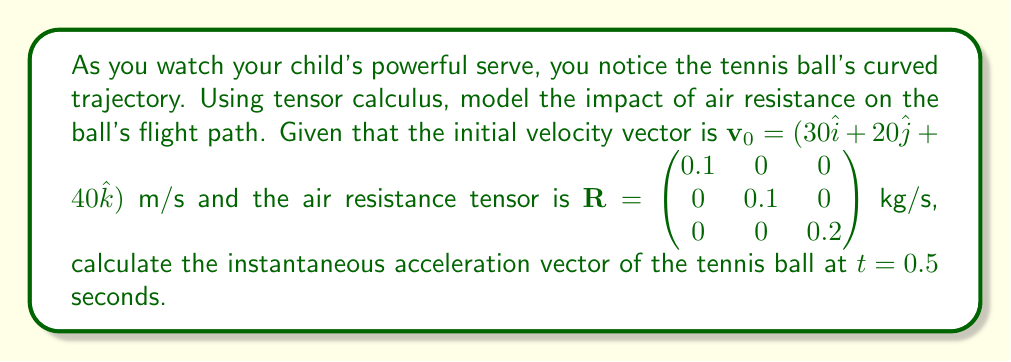Can you solve this math problem? To solve this problem, we'll follow these steps:

1) The equation of motion for a body under air resistance is:

   $$m\frac{d\mathbf{v}}{dt} = m\mathbf{g} - \mathbf{R}\mathbf{v}$$

   where $m$ is the mass of the tennis ball, $\mathbf{g}$ is the gravitational acceleration vector, and $\mathbf{R}$ is the air resistance tensor.

2) The gravitational acceleration vector is $\mathbf{g} = (0, 0, -9.8)$ m/s².

3) We need to find $\mathbf{v}$ at $t = 0.5$ s. We can use the equation:

   $$\mathbf{v}(t) = \mathbf{v}_0 e^{-\frac{\mathbf{R}}{m}t}$$

4) Assuming a standard tennis ball mass of 0.058 kg, we can calculate:

   $$\frac{\mathbf{R}}{m} = \begin{pmatrix} 1.72 & 0 & 0 \\ 0 & 1.72 & 0 \\ 0 & 0 & 3.45 \end{pmatrix}$$

5) Now we can calculate $\mathbf{v}(0.5)$:

   $$\mathbf{v}(0.5) = \begin{pmatrix} 30e^{-1.72 \cdot 0.5} \\ 20e^{-1.72 \cdot 0.5} \\ 40e^{-3.45 \cdot 0.5} \end{pmatrix} = \begin{pmatrix} 19.29 \\ 12.86 \\ 17.39 \end{pmatrix}$$

6) We can now calculate the acceleration at $t = 0.5$ s:

   $$\mathbf{a}(0.5) = \mathbf{g} - \frac{\mathbf{R}}{m}\mathbf{v}(0.5)$$

7) Substituting the values:

   $$\mathbf{a}(0.5) = \begin{pmatrix} 0 \\ 0 \\ -9.8 \end{pmatrix} - \begin{pmatrix} 1.72 & 0 & 0 \\ 0 & 1.72 & 0 \\ 0 & 0 & 3.45 \end{pmatrix} \begin{pmatrix} 19.29 \\ 12.86 \\ 17.39 \end{pmatrix}$$

8) Calculating the final result:

   $$\mathbf{a}(0.5) = \begin{pmatrix} -33.18 \\ -22.12 \\ -69.78 \end{pmatrix}$$
Answer: $\mathbf{a}(0.5) = (-33.18, -22.12, -69.78)$ m/s² 